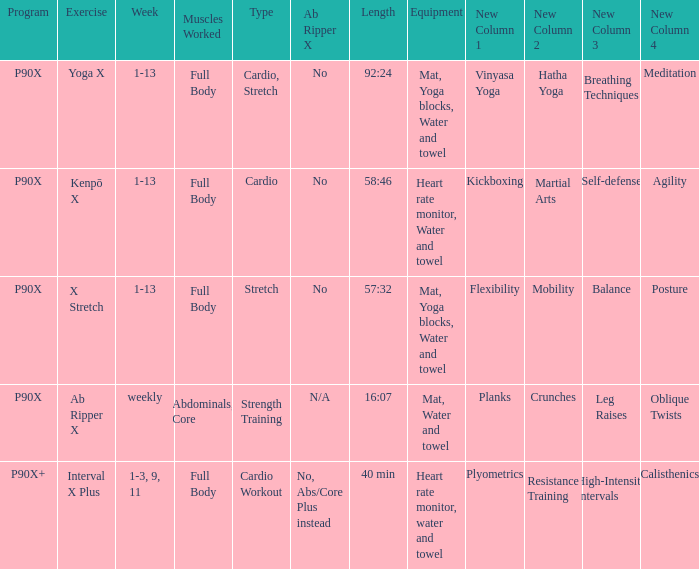What is the training when the devices are heart rate monitor, water, and towel? Kenpō X, Interval X Plus. 